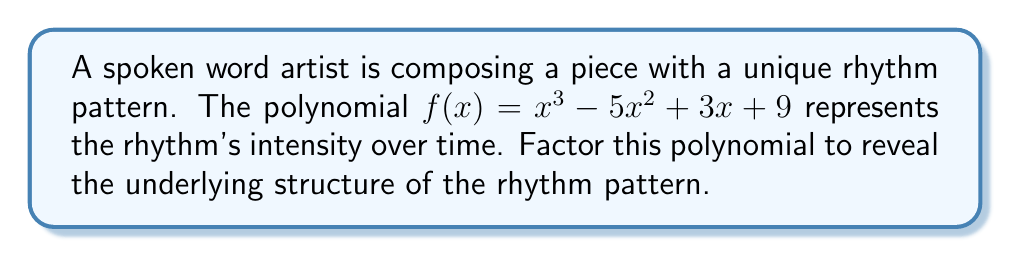Could you help me with this problem? To factor this polynomial, we'll follow these steps:

1) First, check if there are any rational roots using the rational root theorem. The possible rational roots are the factors of the constant term: ±1, ±3, ±9.

2) Using synthetic division or direct substitution, we find that x = -1 is a root.

3) Divide the polynomial by (x + 1):

   $x^3 - 5x^2 + 3x + 9 = (x + 1)(x^2 - 6x + 9)$

4) The quadratic factor $x^2 - 6x + 9$ can be factored further:

   $x^2 - 6x + 9 = (x - 3)^2$

   This is because it's a perfect square trinomial: $a^2 - 2ab + b^2 = (a-b)^2$

5) Combining all factors:

   $f(x) = x^3 - 5x^2 + 3x + 9 = (x + 1)(x - 3)^2$

This factorization reveals that the rhythm pattern has one simple beat change (represented by the linear factor x + 1) and a repeated, more complex change (represented by the squared factor (x - 3)^2).
Answer: $f(x) = (x + 1)(x - 3)^2$ 